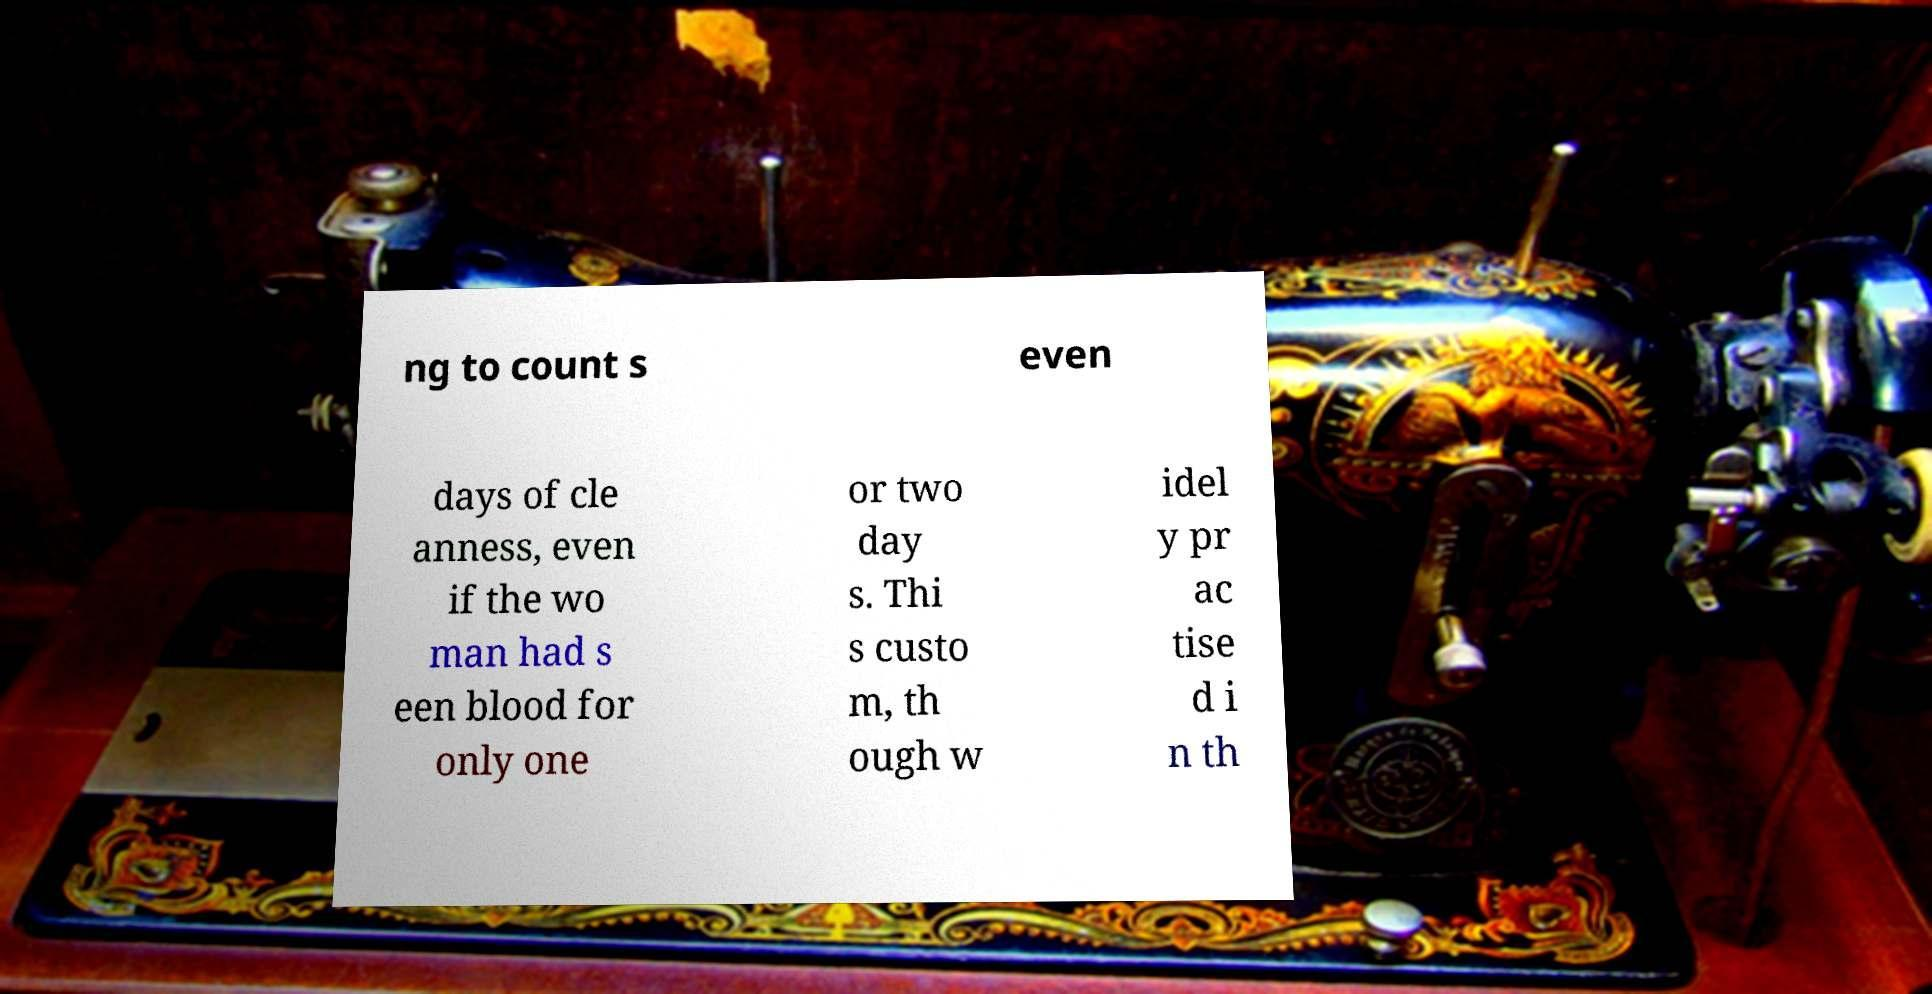What messages or text are displayed in this image? I need them in a readable, typed format. ng to count s even days of cle anness, even if the wo man had s een blood for only one or two day s. Thi s custo m, th ough w idel y pr ac tise d i n th 